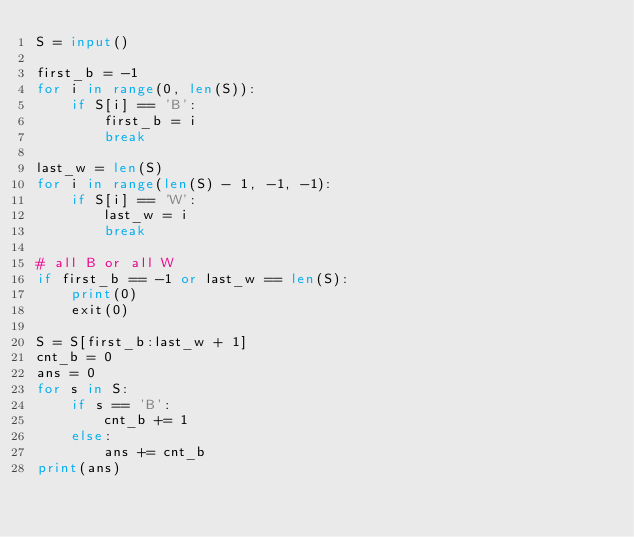<code> <loc_0><loc_0><loc_500><loc_500><_Python_>S = input()

first_b = -1
for i in range(0, len(S)):
    if S[i] == 'B':
        first_b = i
        break

last_w = len(S)
for i in range(len(S) - 1, -1, -1):
    if S[i] == 'W':
        last_w = i
        break

# all B or all W
if first_b == -1 or last_w == len(S):
    print(0)
    exit(0)

S = S[first_b:last_w + 1]
cnt_b = 0
ans = 0
for s in S:
    if s == 'B':
        cnt_b += 1
    else:
        ans += cnt_b
print(ans)
</code> 